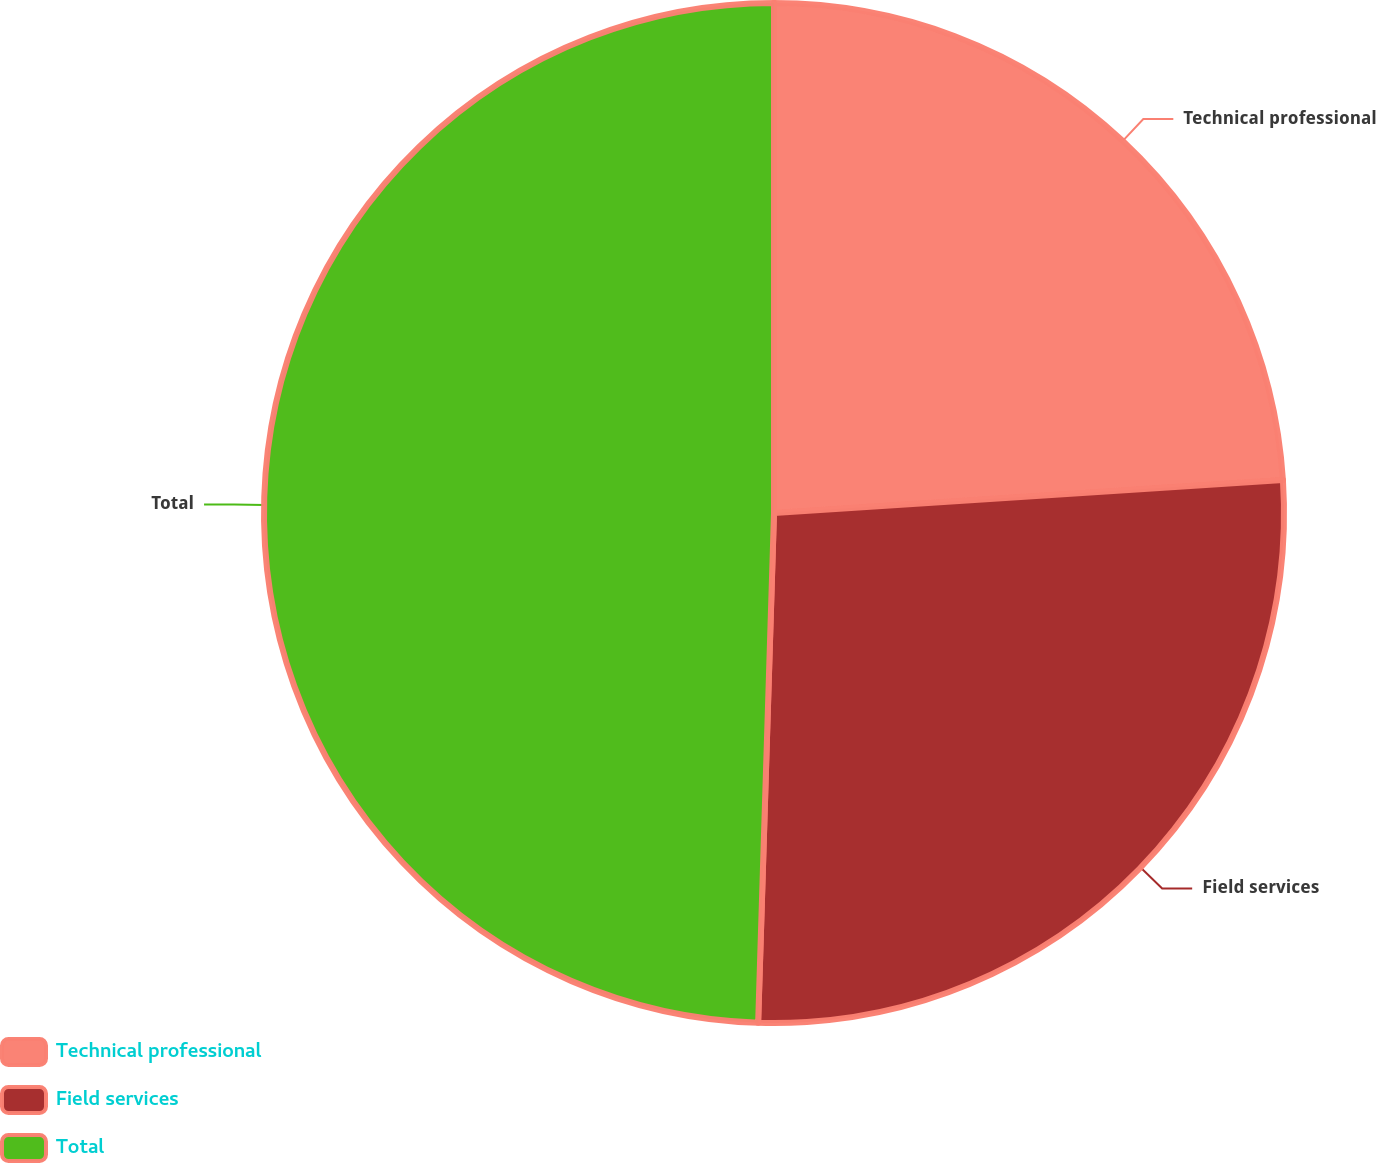<chart> <loc_0><loc_0><loc_500><loc_500><pie_chart><fcel>Technical professional<fcel>Field services<fcel>Total<nl><fcel>23.97%<fcel>26.52%<fcel>49.5%<nl></chart> 